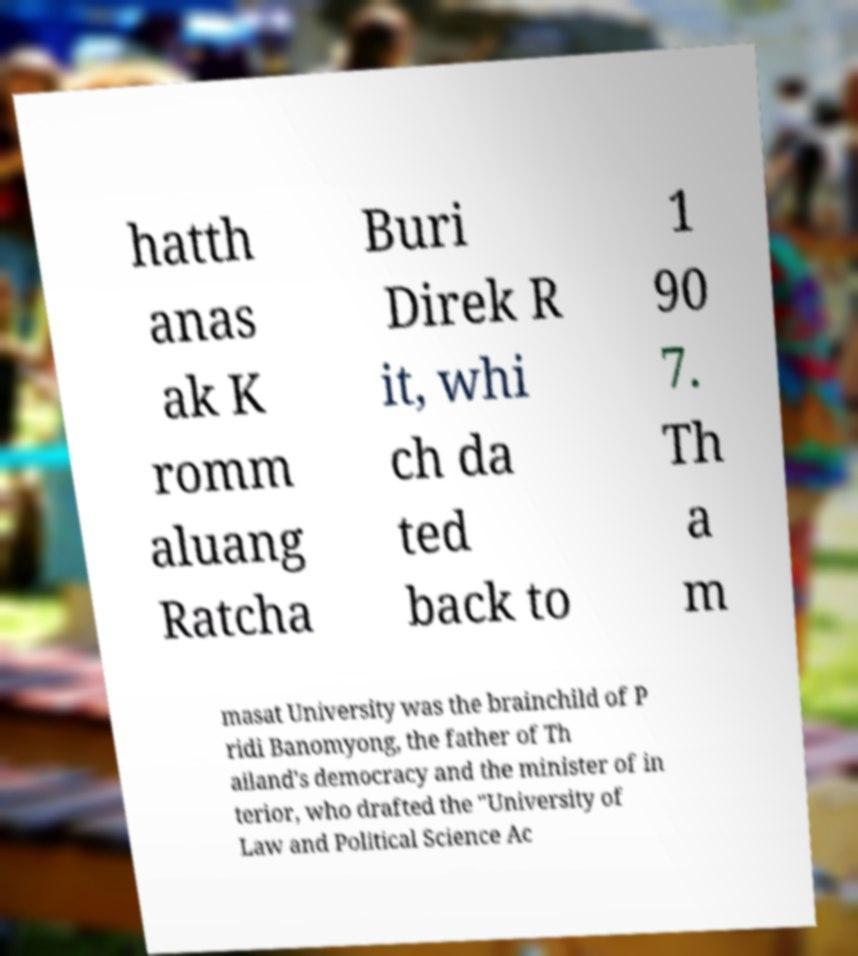I need the written content from this picture converted into text. Can you do that? hatth anas ak K romm aluang Ratcha Buri Direk R it, whi ch da ted back to 1 90 7. Th a m masat University was the brainchild of P ridi Banomyong, the father of Th ailand's democracy and the minister of in terior, who drafted the "University of Law and Political Science Ac 